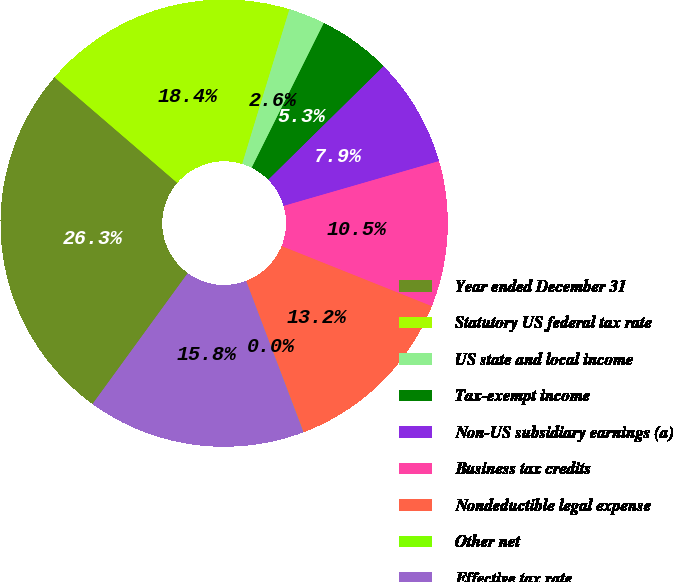Convert chart to OTSL. <chart><loc_0><loc_0><loc_500><loc_500><pie_chart><fcel>Year ended December 31<fcel>Statutory US federal tax rate<fcel>US state and local income<fcel>Tax-exempt income<fcel>Non-US subsidiary earnings (a)<fcel>Business tax credits<fcel>Nondeductible legal expense<fcel>Other net<fcel>Effective tax rate<nl><fcel>26.3%<fcel>18.41%<fcel>2.64%<fcel>5.27%<fcel>7.9%<fcel>10.53%<fcel>13.16%<fcel>0.01%<fcel>15.78%<nl></chart> 